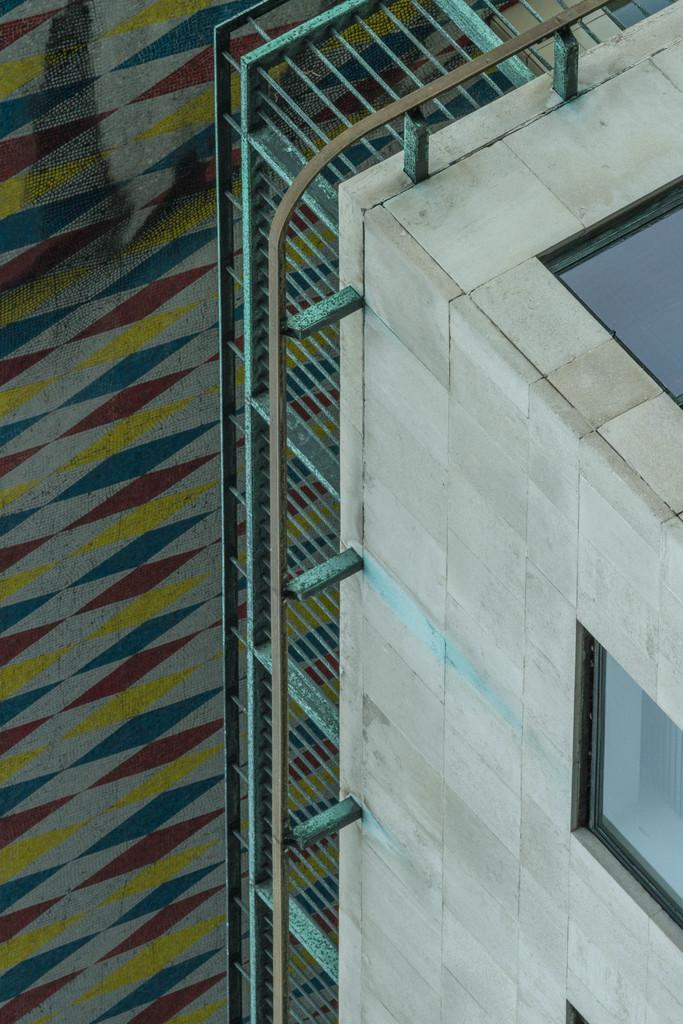What type of structure is visible in the image? There is a building in the image. What feature can be seen on the building? The building has windows. Is there any additional architectural element associated with the building? Yes, there is a railing associated with the building. What can be seen to the left of the building? There is a surface with yellow, red, and blue colors to the left of the building. How many eggs can be seen balancing on the railing in the image? There are no eggs present in the image, and therefore no eggs can be seen balancing on the railing. 